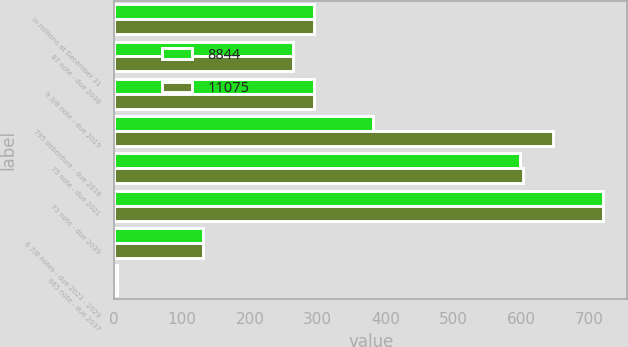<chart> <loc_0><loc_0><loc_500><loc_500><stacked_bar_chart><ecel><fcel>In millions at December 31<fcel>87 note - due 2038<fcel>9 3/8 note - due 2019<fcel>795 debenture - due 2018<fcel>75 note - due 2021<fcel>73 note - due 2039<fcel>6 7/8 notes - due 2023 - 2029<fcel>665 note - due 2037<nl><fcel>8844<fcel>295<fcel>264<fcel>295<fcel>382<fcel>598<fcel>721<fcel>131<fcel>4<nl><fcel>11075<fcel>295<fcel>264<fcel>295<fcel>648<fcel>603<fcel>721<fcel>131<fcel>4<nl></chart> 